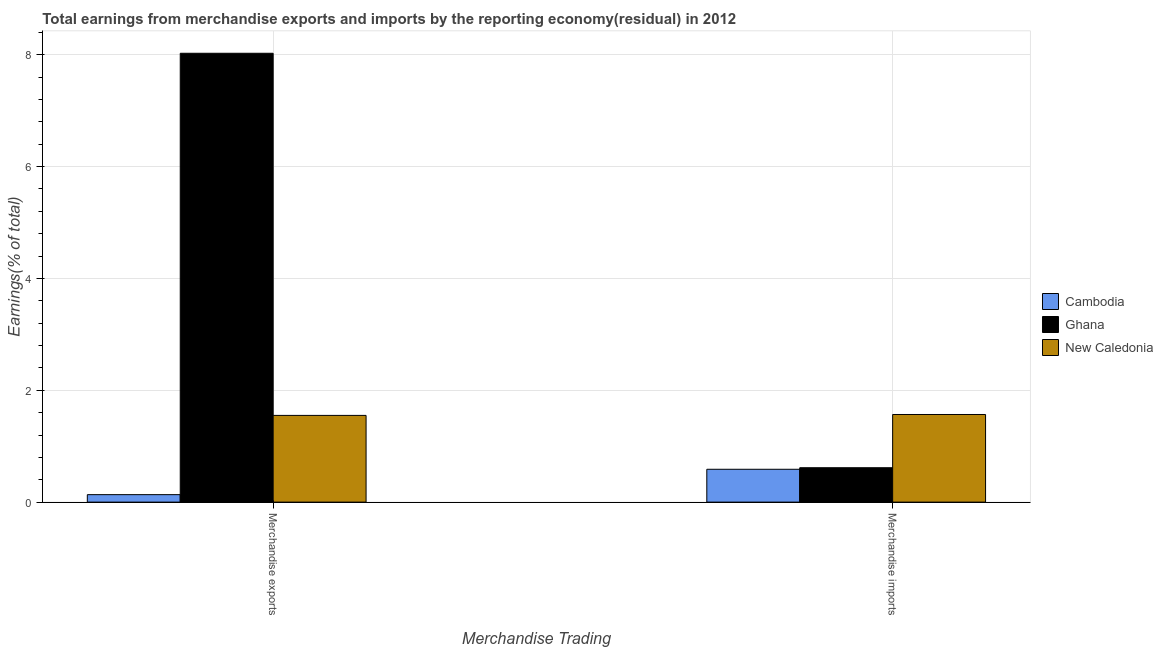Are the number of bars per tick equal to the number of legend labels?
Your answer should be very brief. Yes. How many bars are there on the 2nd tick from the left?
Your answer should be compact. 3. How many bars are there on the 1st tick from the right?
Provide a short and direct response. 3. What is the label of the 2nd group of bars from the left?
Ensure brevity in your answer.  Merchandise imports. What is the earnings from merchandise imports in Ghana?
Your response must be concise. 0.62. Across all countries, what is the maximum earnings from merchandise exports?
Provide a succinct answer. 8.03. Across all countries, what is the minimum earnings from merchandise imports?
Your response must be concise. 0.59. In which country was the earnings from merchandise imports minimum?
Your answer should be very brief. Cambodia. What is the total earnings from merchandise imports in the graph?
Provide a succinct answer. 2.77. What is the difference between the earnings from merchandise imports in Cambodia and that in New Caledonia?
Your answer should be very brief. -0.98. What is the difference between the earnings from merchandise imports in Ghana and the earnings from merchandise exports in New Caledonia?
Offer a very short reply. -0.94. What is the average earnings from merchandise exports per country?
Your response must be concise. 3.24. What is the difference between the earnings from merchandise imports and earnings from merchandise exports in Ghana?
Offer a very short reply. -7.41. What is the ratio of the earnings from merchandise imports in Ghana to that in New Caledonia?
Provide a short and direct response. 0.39. Is the earnings from merchandise exports in Cambodia less than that in New Caledonia?
Make the answer very short. Yes. What does the 2nd bar from the left in Merchandise imports represents?
Provide a short and direct response. Ghana. What does the 2nd bar from the right in Merchandise imports represents?
Keep it short and to the point. Ghana. How many bars are there?
Offer a very short reply. 6. What is the difference between two consecutive major ticks on the Y-axis?
Your answer should be very brief. 2. Are the values on the major ticks of Y-axis written in scientific E-notation?
Your response must be concise. No. How are the legend labels stacked?
Make the answer very short. Vertical. What is the title of the graph?
Ensure brevity in your answer.  Total earnings from merchandise exports and imports by the reporting economy(residual) in 2012. Does "Australia" appear as one of the legend labels in the graph?
Provide a succinct answer. No. What is the label or title of the X-axis?
Keep it short and to the point. Merchandise Trading. What is the label or title of the Y-axis?
Offer a terse response. Earnings(% of total). What is the Earnings(% of total) in Cambodia in Merchandise exports?
Your response must be concise. 0.13. What is the Earnings(% of total) in Ghana in Merchandise exports?
Offer a very short reply. 8.03. What is the Earnings(% of total) in New Caledonia in Merchandise exports?
Provide a succinct answer. 1.55. What is the Earnings(% of total) of Cambodia in Merchandise imports?
Give a very brief answer. 0.59. What is the Earnings(% of total) in Ghana in Merchandise imports?
Provide a succinct answer. 0.62. What is the Earnings(% of total) in New Caledonia in Merchandise imports?
Your response must be concise. 1.57. Across all Merchandise Trading, what is the maximum Earnings(% of total) in Cambodia?
Your answer should be compact. 0.59. Across all Merchandise Trading, what is the maximum Earnings(% of total) in Ghana?
Provide a short and direct response. 8.03. Across all Merchandise Trading, what is the maximum Earnings(% of total) of New Caledonia?
Provide a succinct answer. 1.57. Across all Merchandise Trading, what is the minimum Earnings(% of total) of Cambodia?
Your answer should be very brief. 0.13. Across all Merchandise Trading, what is the minimum Earnings(% of total) in Ghana?
Ensure brevity in your answer.  0.62. Across all Merchandise Trading, what is the minimum Earnings(% of total) in New Caledonia?
Ensure brevity in your answer.  1.55. What is the total Earnings(% of total) in Cambodia in the graph?
Give a very brief answer. 0.72. What is the total Earnings(% of total) in Ghana in the graph?
Make the answer very short. 8.64. What is the total Earnings(% of total) of New Caledonia in the graph?
Your response must be concise. 3.12. What is the difference between the Earnings(% of total) of Cambodia in Merchandise exports and that in Merchandise imports?
Your response must be concise. -0.45. What is the difference between the Earnings(% of total) in Ghana in Merchandise exports and that in Merchandise imports?
Your response must be concise. 7.41. What is the difference between the Earnings(% of total) in New Caledonia in Merchandise exports and that in Merchandise imports?
Give a very brief answer. -0.02. What is the difference between the Earnings(% of total) in Cambodia in Merchandise exports and the Earnings(% of total) in Ghana in Merchandise imports?
Your response must be concise. -0.48. What is the difference between the Earnings(% of total) in Cambodia in Merchandise exports and the Earnings(% of total) in New Caledonia in Merchandise imports?
Ensure brevity in your answer.  -1.43. What is the difference between the Earnings(% of total) of Ghana in Merchandise exports and the Earnings(% of total) of New Caledonia in Merchandise imports?
Make the answer very short. 6.46. What is the average Earnings(% of total) in Cambodia per Merchandise Trading?
Make the answer very short. 0.36. What is the average Earnings(% of total) in Ghana per Merchandise Trading?
Ensure brevity in your answer.  4.32. What is the average Earnings(% of total) of New Caledonia per Merchandise Trading?
Keep it short and to the point. 1.56. What is the difference between the Earnings(% of total) of Cambodia and Earnings(% of total) of Ghana in Merchandise exports?
Offer a very short reply. -7.89. What is the difference between the Earnings(% of total) in Cambodia and Earnings(% of total) in New Caledonia in Merchandise exports?
Your answer should be compact. -1.42. What is the difference between the Earnings(% of total) of Ghana and Earnings(% of total) of New Caledonia in Merchandise exports?
Provide a short and direct response. 6.47. What is the difference between the Earnings(% of total) of Cambodia and Earnings(% of total) of Ghana in Merchandise imports?
Your answer should be very brief. -0.03. What is the difference between the Earnings(% of total) in Cambodia and Earnings(% of total) in New Caledonia in Merchandise imports?
Give a very brief answer. -0.98. What is the difference between the Earnings(% of total) in Ghana and Earnings(% of total) in New Caledonia in Merchandise imports?
Offer a terse response. -0.95. What is the ratio of the Earnings(% of total) of Cambodia in Merchandise exports to that in Merchandise imports?
Offer a very short reply. 0.23. What is the ratio of the Earnings(% of total) of Ghana in Merchandise exports to that in Merchandise imports?
Keep it short and to the point. 13.05. What is the ratio of the Earnings(% of total) of New Caledonia in Merchandise exports to that in Merchandise imports?
Give a very brief answer. 0.99. What is the difference between the highest and the second highest Earnings(% of total) of Cambodia?
Ensure brevity in your answer.  0.45. What is the difference between the highest and the second highest Earnings(% of total) of Ghana?
Provide a succinct answer. 7.41. What is the difference between the highest and the second highest Earnings(% of total) in New Caledonia?
Your answer should be very brief. 0.02. What is the difference between the highest and the lowest Earnings(% of total) of Cambodia?
Offer a terse response. 0.45. What is the difference between the highest and the lowest Earnings(% of total) of Ghana?
Make the answer very short. 7.41. What is the difference between the highest and the lowest Earnings(% of total) of New Caledonia?
Keep it short and to the point. 0.02. 